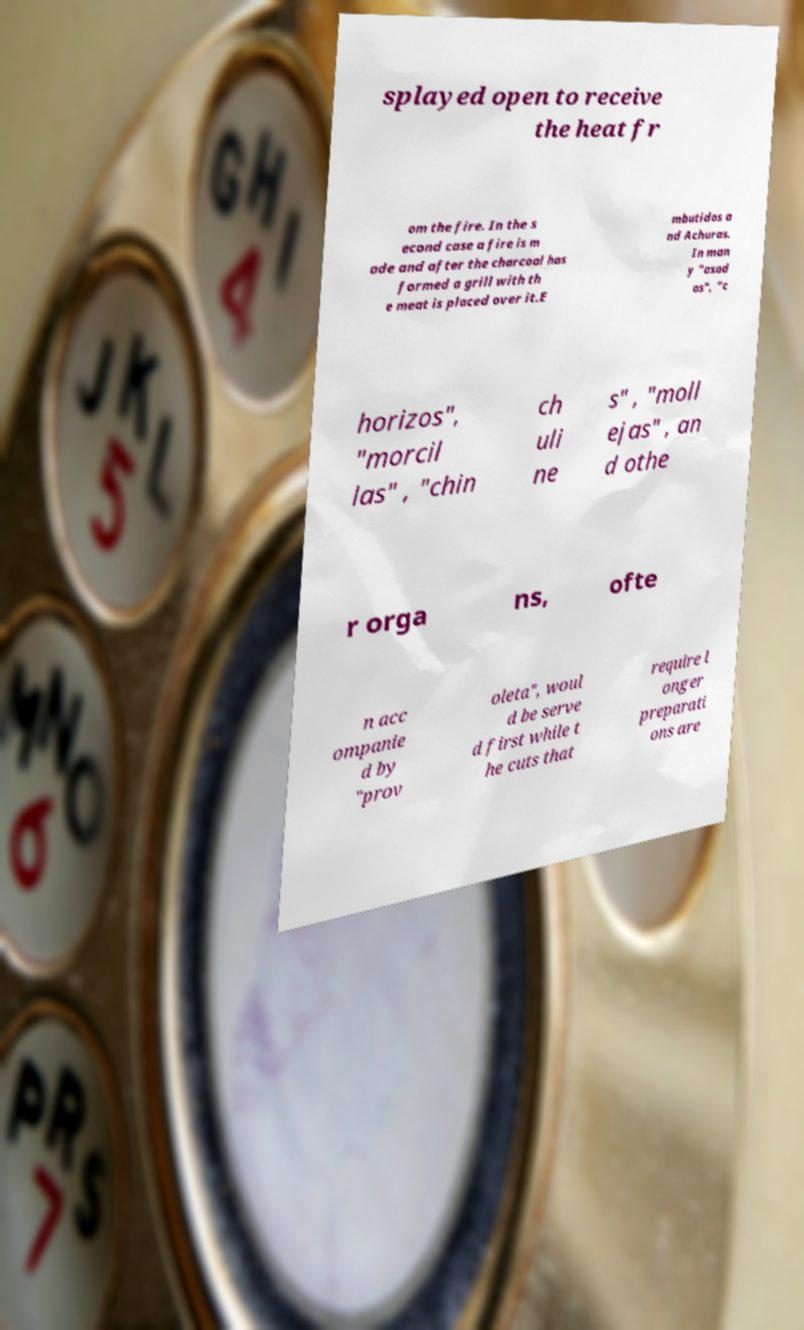Can you accurately transcribe the text from the provided image for me? splayed open to receive the heat fr om the fire. In the s econd case a fire is m ade and after the charcoal has formed a grill with th e meat is placed over it.E mbutidos a nd Achuras. In man y "asad os", "c horizos", "morcil las" , "chin ch uli ne s" , "moll ejas" , an d othe r orga ns, ofte n acc ompanie d by "prov oleta", woul d be serve d first while t he cuts that require l onger preparati ons are 